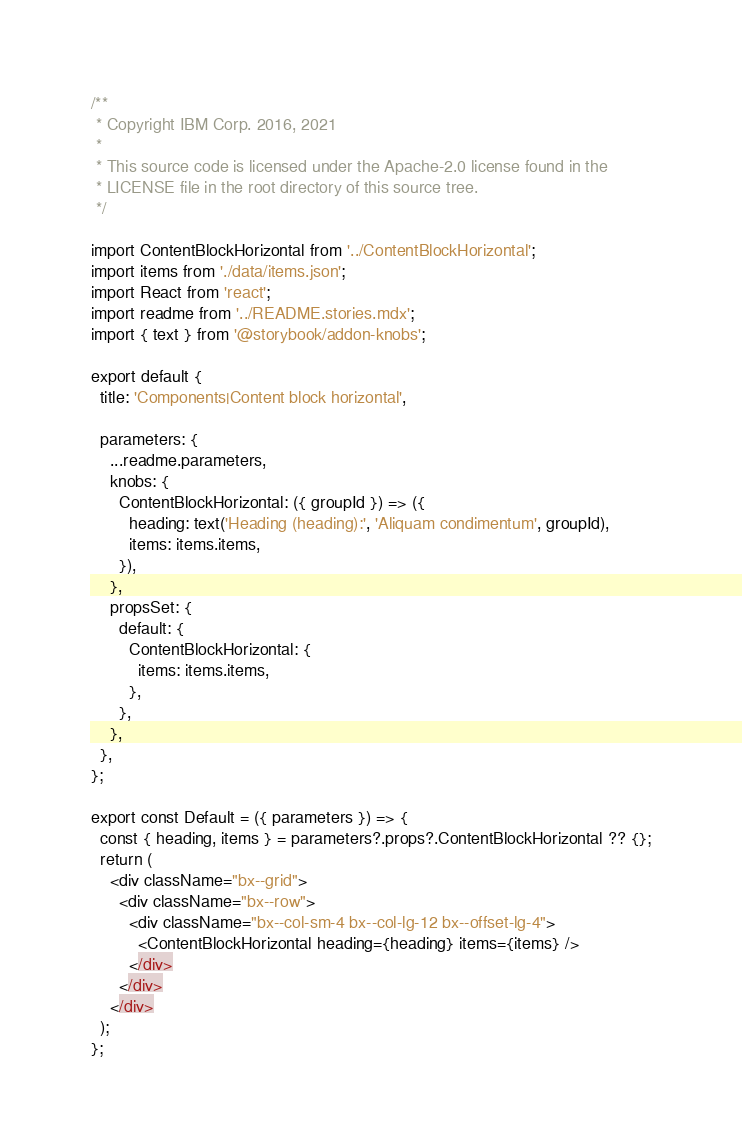Convert code to text. <code><loc_0><loc_0><loc_500><loc_500><_JavaScript_>/**
 * Copyright IBM Corp. 2016, 2021
 *
 * This source code is licensed under the Apache-2.0 license found in the
 * LICENSE file in the root directory of this source tree.
 */

import ContentBlockHorizontal from '../ContentBlockHorizontal';
import items from './data/items.json';
import React from 'react';
import readme from '../README.stories.mdx';
import { text } from '@storybook/addon-knobs';

export default {
  title: 'Components|Content block horizontal',

  parameters: {
    ...readme.parameters,
    knobs: {
      ContentBlockHorizontal: ({ groupId }) => ({
        heading: text('Heading (heading):', 'Aliquam condimentum', groupId),
        items: items.items,
      }),
    },
    propsSet: {
      default: {
        ContentBlockHorizontal: {
          items: items.items,
        },
      },
    },
  },
};

export const Default = ({ parameters }) => {
  const { heading, items } = parameters?.props?.ContentBlockHorizontal ?? {};
  return (
    <div className="bx--grid">
      <div className="bx--row">
        <div className="bx--col-sm-4 bx--col-lg-12 bx--offset-lg-4">
          <ContentBlockHorizontal heading={heading} items={items} />
        </div>
      </div>
    </div>
  );
};
</code> 